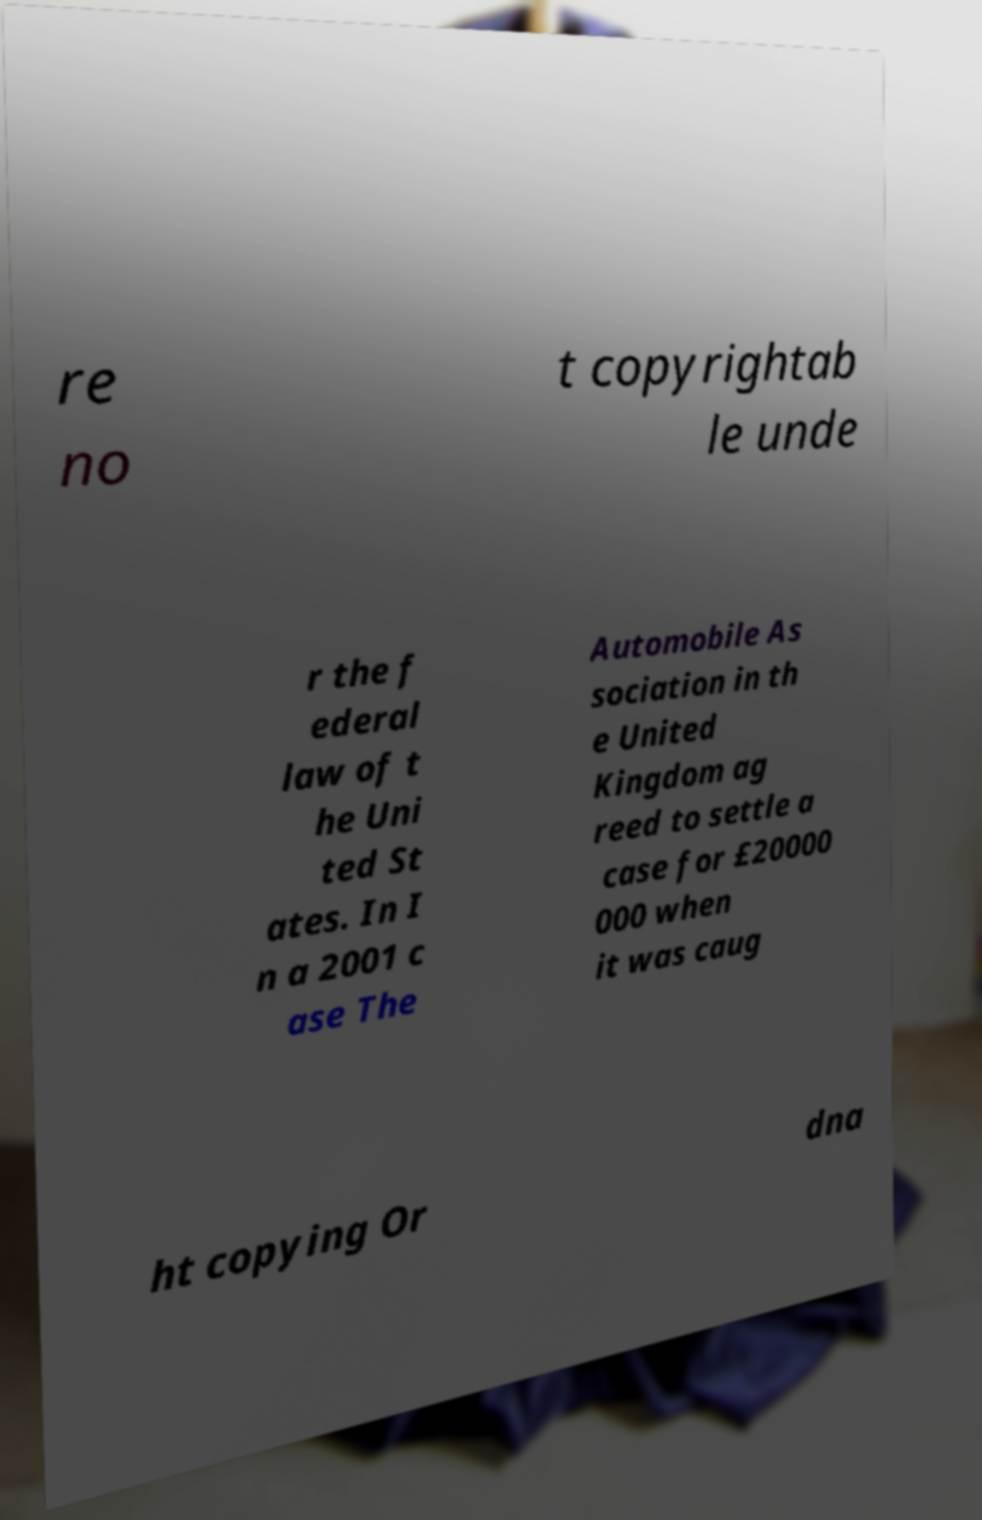What messages or text are displayed in this image? I need them in a readable, typed format. re no t copyrightab le unde r the f ederal law of t he Uni ted St ates. In I n a 2001 c ase The Automobile As sociation in th e United Kingdom ag reed to settle a case for £20000 000 when it was caug ht copying Or dna 